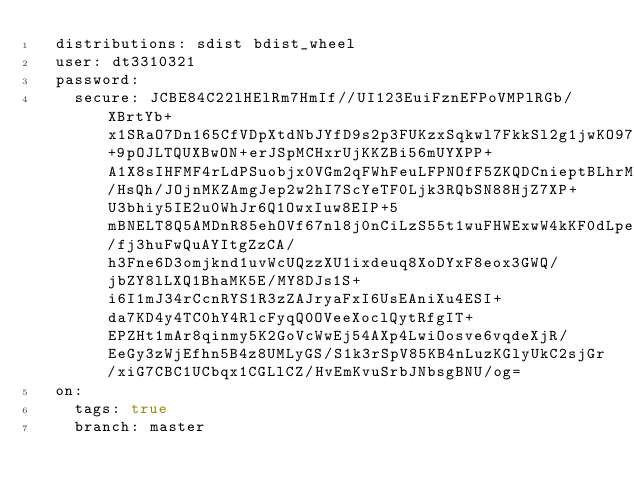<code> <loc_0><loc_0><loc_500><loc_500><_YAML_>  distributions: sdist bdist_wheel
  user: dt3310321
  password:
    secure: JCBE84C22lHElRm7HmIf//UI123EuiFznEFPoVMPlRGb/XBrtYb+x1SRaO7Dn165CfVDpXtdNbJYfD9s2p3FUKzxSqkwl7FkkSl2g1jwKO97gKBPGxozBN+9pOJLTQUXBwON+erJSpMCHxrUjKKZBi56mUYXPP+A1X8sIHFMF4rLdPSuobjx0VGm2qFWhFeuLFPNOfF5ZKQDCnieptBLhrMXRcxyhZja/HsQh/JOjnMKZAmgJep2w2hI7ScYeTF0Ljk3RQbSN88HjZ7XP+U3bhiy5IE2u0WhJr6Q1OwxIuw8EIP+5mBNELT8Q5AMDnR85ehOVf67nl8j0nCiLzS55t1wuFHWExwW4kKF0dLpeV/fj3huFwQuAYItgZzCA/h3Fne6D3omjknd1uvWcUQzzXU1ixdeuq8XoDYxF8eox3GWQ/jbZY8lLXQ1BhaMK5E/MY8DJs1S+i6I1mJ34rCcnRYS1R3zZAJryaFxI6UsEAniXu4ESI+da7KD4y4TC0hY4RlcFyqQ0OVeeXoclQytRfgIT+EPZHt1mAr8qinmy5K2GoVcWwEj54AXp4LwiOosve6vqdeXjR/EeGy3zWjEfhn5B4z8UMLyGS/S1k3rSpV85KB4nLuzKGlyUkC2sjGr/xiG7CBC1UCbqx1CGLlCZ/HvEmKvuSrbJNbsgBNU/og=
  on:
    tags: true
    branch: master
</code> 